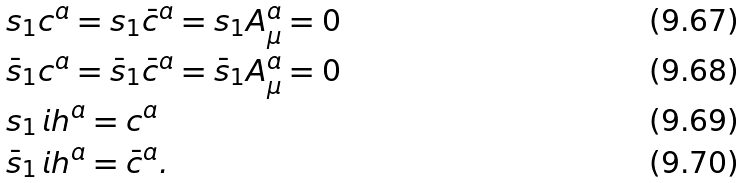<formula> <loc_0><loc_0><loc_500><loc_500>& s _ { 1 } c ^ { a } = s _ { 1 } \bar { c } ^ { a } = s _ { 1 } A _ { \mu } ^ { a } = 0 \\ & \bar { s } _ { 1 } c ^ { a } = \bar { s } _ { 1 } \bar { c } ^ { a } = \bar { s } _ { 1 } A _ { \mu } ^ { a } = 0 \\ & s _ { 1 } \, i h ^ { a } = c ^ { a } \\ & \bar { s } _ { 1 } \, i h ^ { a } = \bar { c } ^ { a } .</formula> 